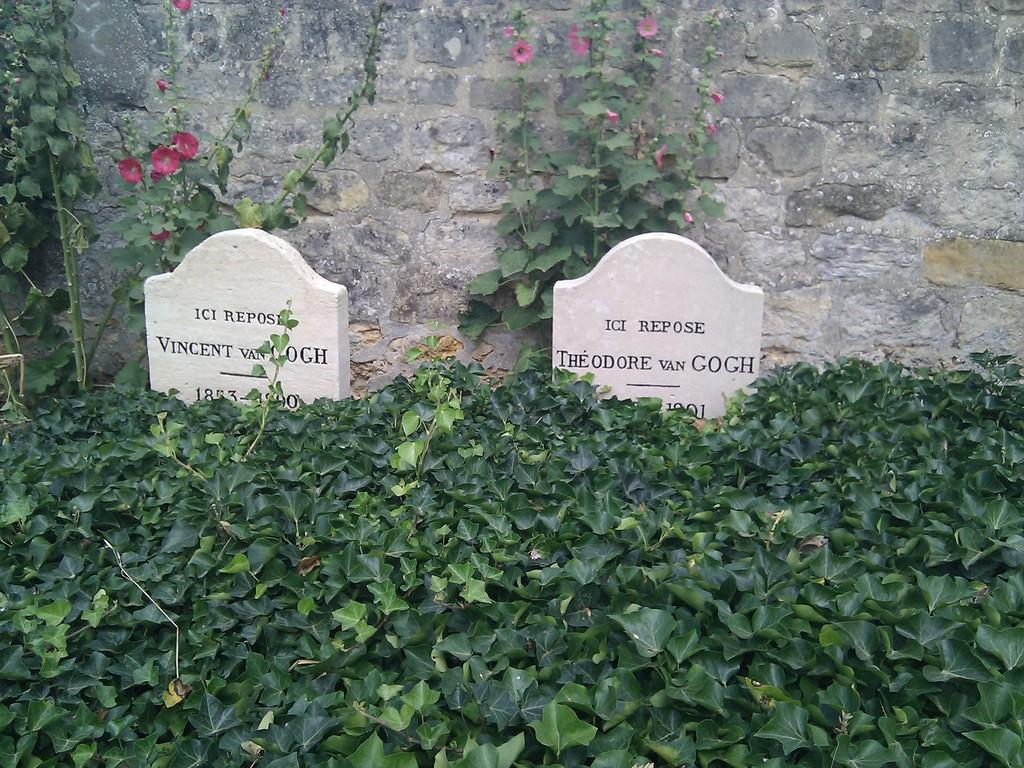<image>
Render a clear and concise summary of the photo. The gravesite for Vincent VanGogh sits next to the burial place of Theodore VanGogh. 